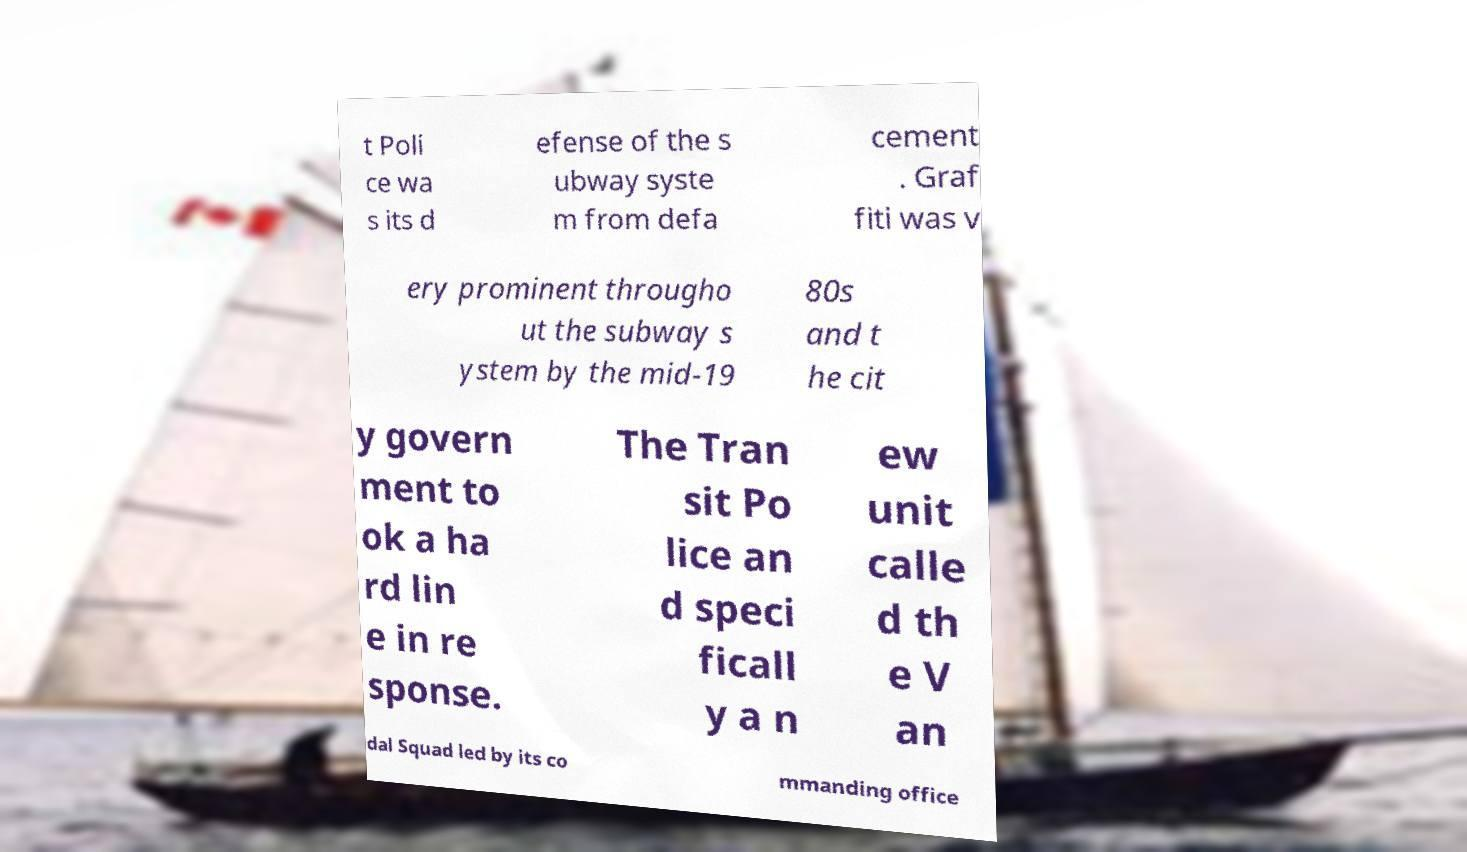There's text embedded in this image that I need extracted. Can you transcribe it verbatim? t Poli ce wa s its d efense of the s ubway syste m from defa cement . Graf fiti was v ery prominent througho ut the subway s ystem by the mid-19 80s and t he cit y govern ment to ok a ha rd lin e in re sponse. The Tran sit Po lice an d speci ficall y a n ew unit calle d th e V an dal Squad led by its co mmanding office 